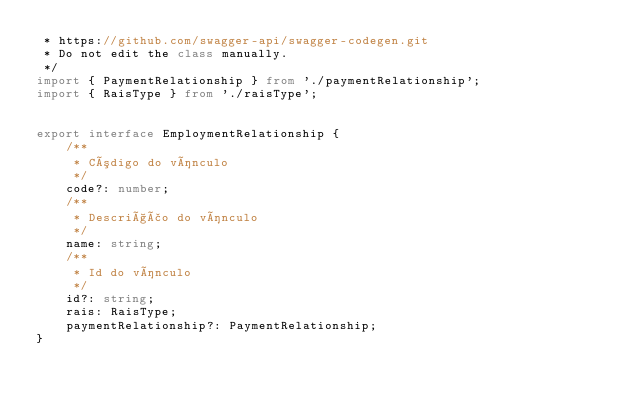<code> <loc_0><loc_0><loc_500><loc_500><_TypeScript_> * https://github.com/swagger-api/swagger-codegen.git
 * Do not edit the class manually.
 */
import { PaymentRelationship } from './paymentRelationship';
import { RaisType } from './raisType';


export interface EmploymentRelationship { 
    /**
     * Código do vínculo
     */
    code?: number;
    /**
     * Descrição do vínculo
     */
    name: string;
    /**
     * Id do vínculo
     */
    id?: string;
    rais: RaisType;
    paymentRelationship?: PaymentRelationship;
}
</code> 